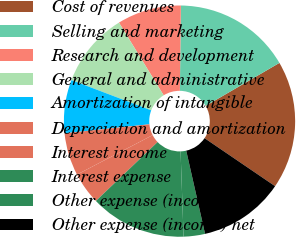Convert chart. <chart><loc_0><loc_0><loc_500><loc_500><pie_chart><fcel>Cost of revenues<fcel>Selling and marketing<fcel>Research and development<fcel>General and administrative<fcel>Amortization of intangible<fcel>Depreciation and amortization<fcel>Interest income<fcel>Interest expense<fcel>Other expense (income)<fcel>Other expense (income) net<nl><fcel>17.91%<fcel>16.42%<fcel>8.96%<fcel>10.45%<fcel>7.46%<fcel>5.97%<fcel>4.48%<fcel>13.43%<fcel>2.99%<fcel>11.94%<nl></chart> 